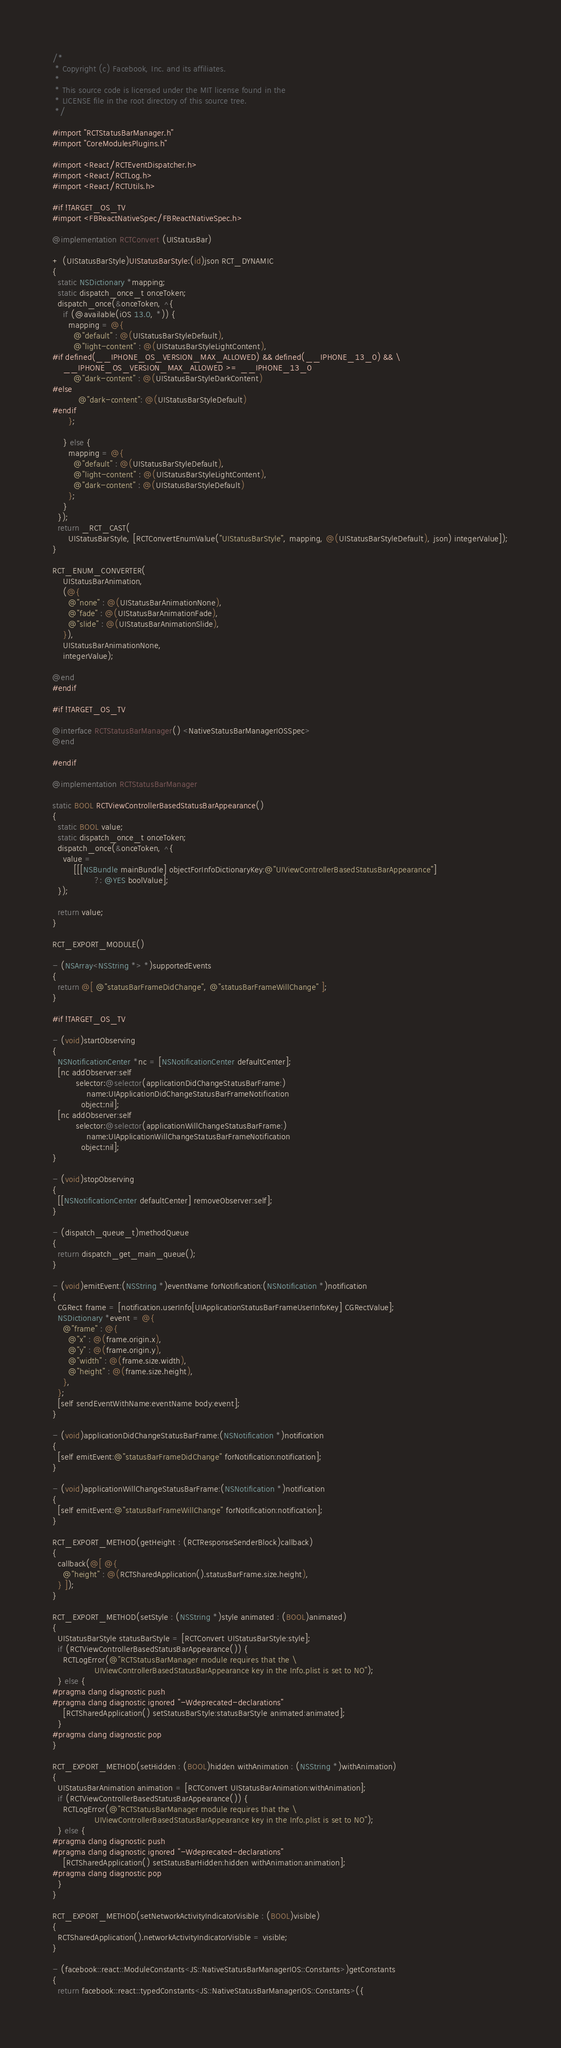Convert code to text. <code><loc_0><loc_0><loc_500><loc_500><_ObjectiveC_>/*
 * Copyright (c) Facebook, Inc. and its affiliates.
 *
 * This source code is licensed under the MIT license found in the
 * LICENSE file in the root directory of this source tree.
 */

#import "RCTStatusBarManager.h"
#import "CoreModulesPlugins.h"

#import <React/RCTEventDispatcher.h>
#import <React/RCTLog.h>
#import <React/RCTUtils.h>

#if !TARGET_OS_TV
#import <FBReactNativeSpec/FBReactNativeSpec.h>

@implementation RCTConvert (UIStatusBar)

+ (UIStatusBarStyle)UIStatusBarStyle:(id)json RCT_DYNAMIC
{
  static NSDictionary *mapping;
  static dispatch_once_t onceToken;
  dispatch_once(&onceToken, ^{
    if (@available(iOS 13.0, *)) {
      mapping = @{
        @"default" : @(UIStatusBarStyleDefault),
        @"light-content" : @(UIStatusBarStyleLightContent),
#if defined(__IPHONE_OS_VERSION_MAX_ALLOWED) && defined(__IPHONE_13_0) && \
    __IPHONE_OS_VERSION_MAX_ALLOWED >= __IPHONE_13_0
        @"dark-content" : @(UIStatusBarStyleDarkContent)
#else
          @"dark-content": @(UIStatusBarStyleDefault)
#endif
      };

    } else {
      mapping = @{
        @"default" : @(UIStatusBarStyleDefault),
        @"light-content" : @(UIStatusBarStyleLightContent),
        @"dark-content" : @(UIStatusBarStyleDefault)
      };
    }
  });
  return _RCT_CAST(
      UIStatusBarStyle, [RCTConvertEnumValue("UIStatusBarStyle", mapping, @(UIStatusBarStyleDefault), json) integerValue]);
}

RCT_ENUM_CONVERTER(
    UIStatusBarAnimation,
    (@{
      @"none" : @(UIStatusBarAnimationNone),
      @"fade" : @(UIStatusBarAnimationFade),
      @"slide" : @(UIStatusBarAnimationSlide),
    }),
    UIStatusBarAnimationNone,
    integerValue);

@end
#endif

#if !TARGET_OS_TV

@interface RCTStatusBarManager() <NativeStatusBarManagerIOSSpec>
@end

#endif

@implementation RCTStatusBarManager

static BOOL RCTViewControllerBasedStatusBarAppearance()
{
  static BOOL value;
  static dispatch_once_t onceToken;
  dispatch_once(&onceToken, ^{
    value =
        [[[NSBundle mainBundle] objectForInfoDictionaryKey:@"UIViewControllerBasedStatusBarAppearance"]
                ?: @YES boolValue];
  });

  return value;
}

RCT_EXPORT_MODULE()

- (NSArray<NSString *> *)supportedEvents
{
  return @[ @"statusBarFrameDidChange", @"statusBarFrameWillChange" ];
}

#if !TARGET_OS_TV

- (void)startObserving
{
  NSNotificationCenter *nc = [NSNotificationCenter defaultCenter];
  [nc addObserver:self
         selector:@selector(applicationDidChangeStatusBarFrame:)
             name:UIApplicationDidChangeStatusBarFrameNotification
           object:nil];
  [nc addObserver:self
         selector:@selector(applicationWillChangeStatusBarFrame:)
             name:UIApplicationWillChangeStatusBarFrameNotification
           object:nil];
}

- (void)stopObserving
{
  [[NSNotificationCenter defaultCenter] removeObserver:self];
}

- (dispatch_queue_t)methodQueue
{
  return dispatch_get_main_queue();
}

- (void)emitEvent:(NSString *)eventName forNotification:(NSNotification *)notification
{
  CGRect frame = [notification.userInfo[UIApplicationStatusBarFrameUserInfoKey] CGRectValue];
  NSDictionary *event = @{
    @"frame" : @{
      @"x" : @(frame.origin.x),
      @"y" : @(frame.origin.y),
      @"width" : @(frame.size.width),
      @"height" : @(frame.size.height),
    },
  };
  [self sendEventWithName:eventName body:event];
}

- (void)applicationDidChangeStatusBarFrame:(NSNotification *)notification
{
  [self emitEvent:@"statusBarFrameDidChange" forNotification:notification];
}

- (void)applicationWillChangeStatusBarFrame:(NSNotification *)notification
{
  [self emitEvent:@"statusBarFrameWillChange" forNotification:notification];
}

RCT_EXPORT_METHOD(getHeight : (RCTResponseSenderBlock)callback)
{
  callback(@[ @{
    @"height" : @(RCTSharedApplication().statusBarFrame.size.height),
  } ]);
}

RCT_EXPORT_METHOD(setStyle : (NSString *)style animated : (BOOL)animated)
{
  UIStatusBarStyle statusBarStyle = [RCTConvert UIStatusBarStyle:style];
  if (RCTViewControllerBasedStatusBarAppearance()) {
    RCTLogError(@"RCTStatusBarManager module requires that the \
                UIViewControllerBasedStatusBarAppearance key in the Info.plist is set to NO");
  } else {
#pragma clang diagnostic push
#pragma clang diagnostic ignored "-Wdeprecated-declarations"
    [RCTSharedApplication() setStatusBarStyle:statusBarStyle animated:animated];
  }
#pragma clang diagnostic pop
}

RCT_EXPORT_METHOD(setHidden : (BOOL)hidden withAnimation : (NSString *)withAnimation)
{
  UIStatusBarAnimation animation = [RCTConvert UIStatusBarAnimation:withAnimation];
  if (RCTViewControllerBasedStatusBarAppearance()) {
    RCTLogError(@"RCTStatusBarManager module requires that the \
                UIViewControllerBasedStatusBarAppearance key in the Info.plist is set to NO");
  } else {
#pragma clang diagnostic push
#pragma clang diagnostic ignored "-Wdeprecated-declarations"
    [RCTSharedApplication() setStatusBarHidden:hidden withAnimation:animation];
#pragma clang diagnostic pop
  }
}

RCT_EXPORT_METHOD(setNetworkActivityIndicatorVisible : (BOOL)visible)
{
  RCTSharedApplication().networkActivityIndicatorVisible = visible;
}

- (facebook::react::ModuleConstants<JS::NativeStatusBarManagerIOS::Constants>)getConstants
{
  return facebook::react::typedConstants<JS::NativeStatusBarManagerIOS::Constants>({</code> 